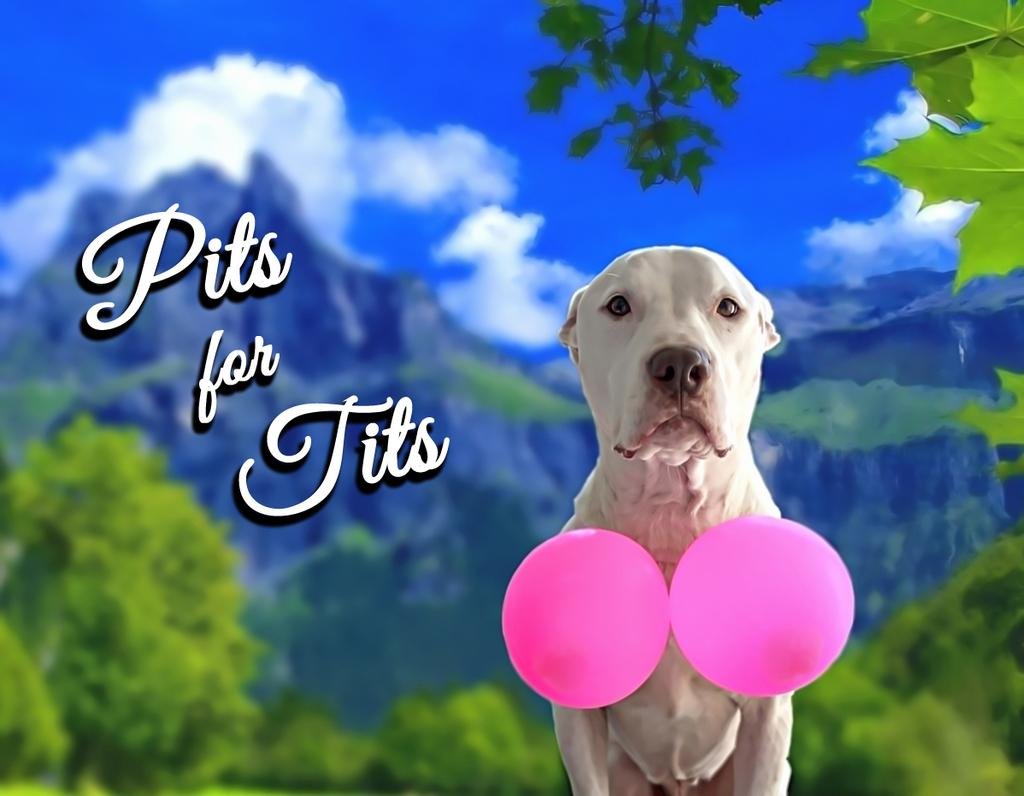What can be seen floating in the image? There are balloons in the image. What type of animal is present in the image? There is a dog in the image. What is on the poster in the image? There is a poster with something written on it. How would you describe the background of the image? The background of the image is blurred. What can be seen in the sky in the image? Clouds are visible in the image. What type of natural features can be seen in the image? There are mountains and trees present in the image. How many girls are sitting on the dog in the image? There are no girls present in the image, and the dog is not being used as a seat. What type of wood is used to construct the mountains in the image? The mountains in the image are natural geological formations and not made of wood. 